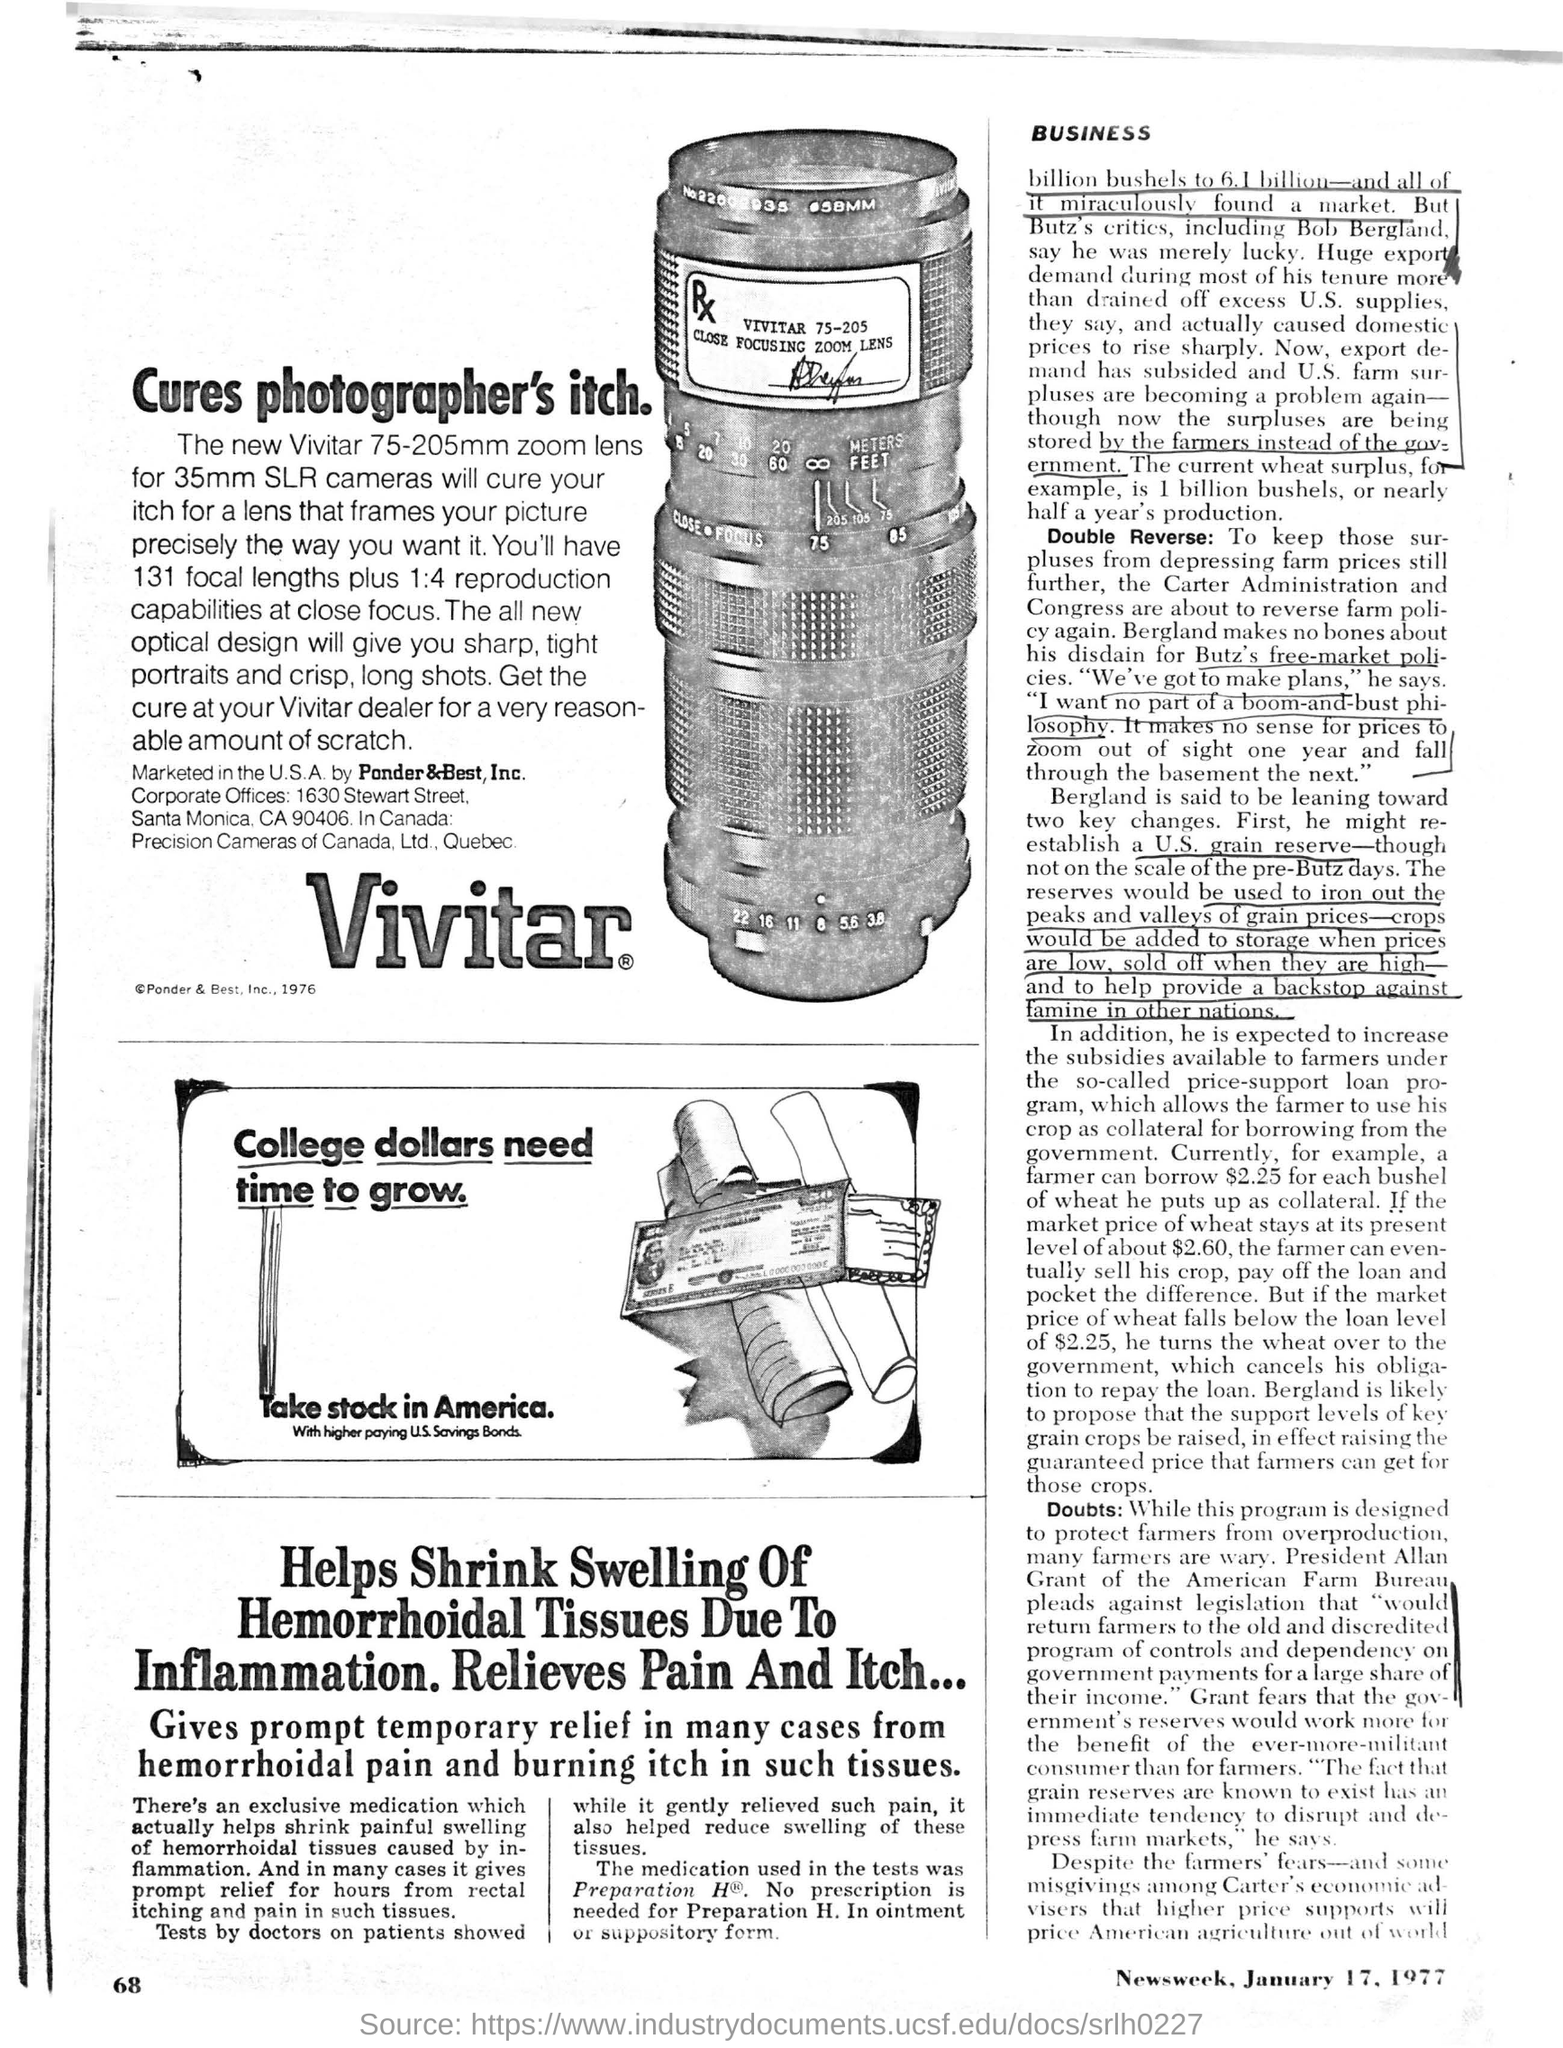Highlight a few significant elements in this photo. Take Stock in America," a title located in the middle of the page in a box, highlights the possibility of earning higher interest on U.S. Savings Bonds. The company that markets Vivitar in the United States is Pander & Best, Inc. The advertisement states that a zoom lens suitable for use with 35mm SLR cameras, with a focal length ranging from 75mm to 205mm, is being advertised. The advertisement mentioned a focal length of 131. The optical design of the lens provides sharp and tight portraits, as well as crisp and long shots, making it an excellent choice for photography enthusiasts. 